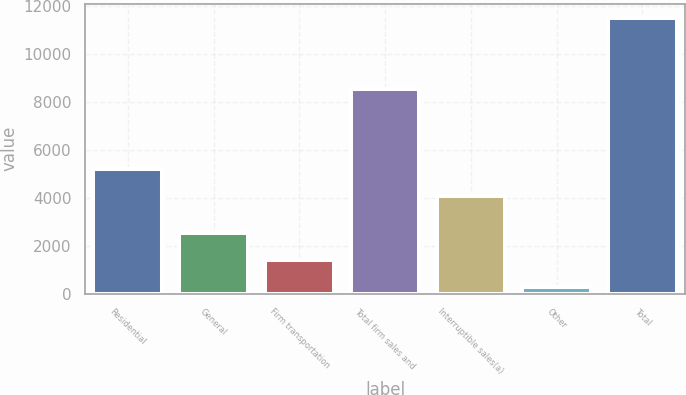Convert chart. <chart><loc_0><loc_0><loc_500><loc_500><bar_chart><fcel>Residential<fcel>General<fcel>Firm transportation<fcel>Total firm sales and<fcel>Interruptible sales(a)<fcel>Other<fcel>Total<nl><fcel>5196.8<fcel>2553.8<fcel>1431<fcel>8532<fcel>4074<fcel>303<fcel>11531<nl></chart> 